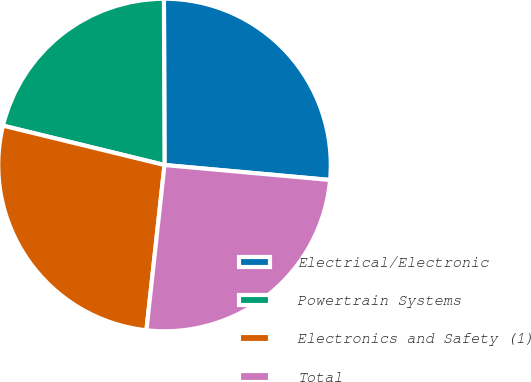Convert chart. <chart><loc_0><loc_0><loc_500><loc_500><pie_chart><fcel>Electrical/Electronic<fcel>Powertrain Systems<fcel>Electronics and Safety (1)<fcel>Total<nl><fcel>26.49%<fcel>21.14%<fcel>27.07%<fcel>25.3%<nl></chart> 